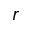<formula> <loc_0><loc_0><loc_500><loc_500>r</formula> 